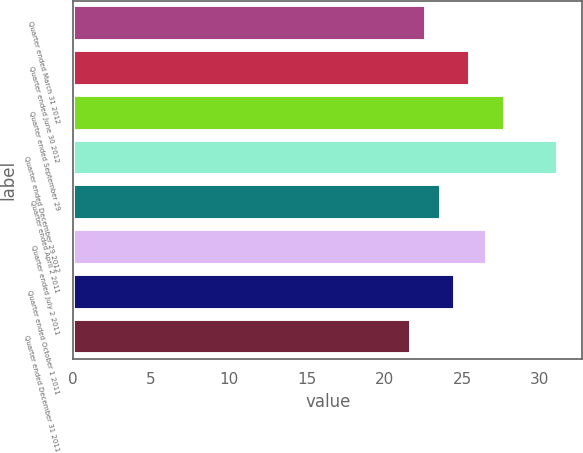<chart> <loc_0><loc_0><loc_500><loc_500><bar_chart><fcel>Quarter ended March 31 2012<fcel>Quarter ended June 30 2012<fcel>Quarter ended September 29<fcel>Quarter ended December 29 2012<fcel>Quarter ended April 2 2011<fcel>Quarter ended July 2 2011<fcel>Quarter ended October 1 2011<fcel>Quarter ended December 31 2011<nl><fcel>22.68<fcel>25.5<fcel>27.74<fcel>31.17<fcel>23.62<fcel>26.59<fcel>24.56<fcel>21.74<nl></chart> 